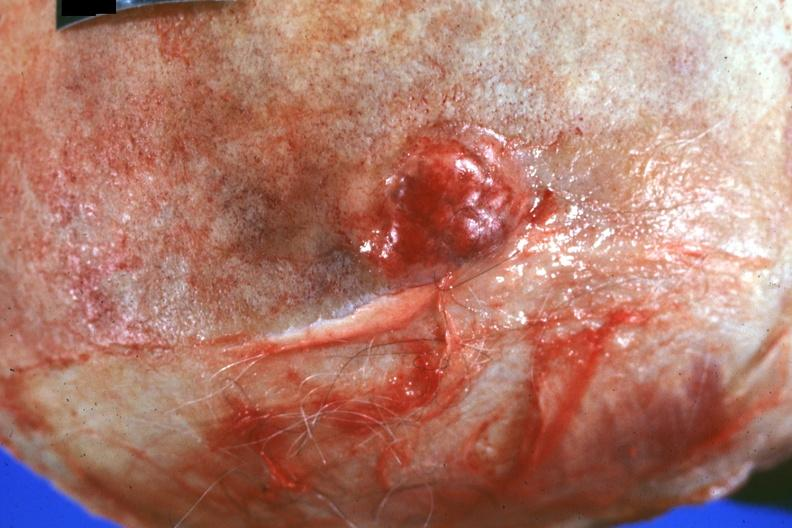s metastatic carcinoma present?
Answer the question using a single word or phrase. Yes 